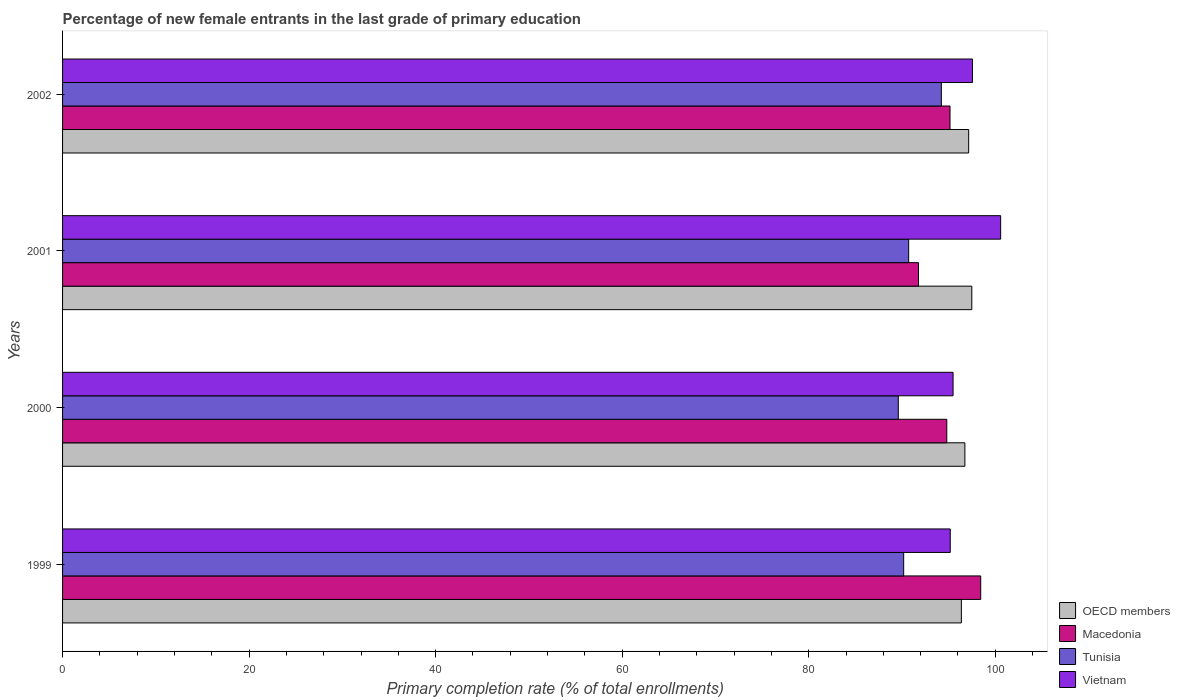How many different coloured bars are there?
Your answer should be compact. 4. How many groups of bars are there?
Your answer should be very brief. 4. Are the number of bars on each tick of the Y-axis equal?
Keep it short and to the point. Yes. How many bars are there on the 2nd tick from the bottom?
Your answer should be very brief. 4. What is the label of the 3rd group of bars from the top?
Your answer should be very brief. 2000. In how many cases, is the number of bars for a given year not equal to the number of legend labels?
Provide a short and direct response. 0. What is the percentage of new female entrants in Macedonia in 2000?
Offer a very short reply. 94.8. Across all years, what is the maximum percentage of new female entrants in OECD members?
Offer a very short reply. 97.48. Across all years, what is the minimum percentage of new female entrants in Macedonia?
Offer a terse response. 91.77. In which year was the percentage of new female entrants in OECD members maximum?
Provide a succinct answer. 2001. In which year was the percentage of new female entrants in OECD members minimum?
Ensure brevity in your answer.  1999. What is the total percentage of new female entrants in Macedonia in the graph?
Ensure brevity in your answer.  380.16. What is the difference between the percentage of new female entrants in OECD members in 2001 and that in 2002?
Offer a terse response. 0.34. What is the difference between the percentage of new female entrants in OECD members in 2001 and the percentage of new female entrants in Vietnam in 2002?
Keep it short and to the point. -0.07. What is the average percentage of new female entrants in Vietnam per year?
Provide a succinct answer. 97.2. In the year 1999, what is the difference between the percentage of new female entrants in Tunisia and percentage of new female entrants in Vietnam?
Give a very brief answer. -4.99. What is the ratio of the percentage of new female entrants in Vietnam in 1999 to that in 2002?
Make the answer very short. 0.98. What is the difference between the highest and the second highest percentage of new female entrants in Macedonia?
Make the answer very short. 3.29. What is the difference between the highest and the lowest percentage of new female entrants in Vietnam?
Provide a succinct answer. 5.4. Is the sum of the percentage of new female entrants in Vietnam in 2000 and 2001 greater than the maximum percentage of new female entrants in Macedonia across all years?
Keep it short and to the point. Yes. Is it the case that in every year, the sum of the percentage of new female entrants in Tunisia and percentage of new female entrants in OECD members is greater than the sum of percentage of new female entrants in Macedonia and percentage of new female entrants in Vietnam?
Offer a very short reply. No. What does the 1st bar from the top in 2000 represents?
Your answer should be compact. Vietnam. What does the 3rd bar from the bottom in 2001 represents?
Provide a succinct answer. Tunisia. How many years are there in the graph?
Your response must be concise. 4. Are the values on the major ticks of X-axis written in scientific E-notation?
Your answer should be very brief. No. Does the graph contain any zero values?
Give a very brief answer. No. Does the graph contain grids?
Ensure brevity in your answer.  No. What is the title of the graph?
Keep it short and to the point. Percentage of new female entrants in the last grade of primary education. What is the label or title of the X-axis?
Make the answer very short. Primary completion rate (% of total enrollments). What is the Primary completion rate (% of total enrollments) of OECD members in 1999?
Offer a terse response. 96.37. What is the Primary completion rate (% of total enrollments) in Macedonia in 1999?
Offer a terse response. 98.44. What is the Primary completion rate (% of total enrollments) in Tunisia in 1999?
Your answer should be compact. 90.18. What is the Primary completion rate (% of total enrollments) in Vietnam in 1999?
Keep it short and to the point. 95.17. What is the Primary completion rate (% of total enrollments) in OECD members in 2000?
Offer a terse response. 96.74. What is the Primary completion rate (% of total enrollments) of Macedonia in 2000?
Make the answer very short. 94.8. What is the Primary completion rate (% of total enrollments) of Tunisia in 2000?
Your response must be concise. 89.6. What is the Primary completion rate (% of total enrollments) in Vietnam in 2000?
Your answer should be very brief. 95.48. What is the Primary completion rate (% of total enrollments) in OECD members in 2001?
Your answer should be very brief. 97.48. What is the Primary completion rate (% of total enrollments) in Macedonia in 2001?
Make the answer very short. 91.77. What is the Primary completion rate (% of total enrollments) of Tunisia in 2001?
Give a very brief answer. 90.72. What is the Primary completion rate (% of total enrollments) of Vietnam in 2001?
Ensure brevity in your answer.  100.58. What is the Primary completion rate (% of total enrollments) of OECD members in 2002?
Your answer should be very brief. 97.15. What is the Primary completion rate (% of total enrollments) of Macedonia in 2002?
Provide a succinct answer. 95.15. What is the Primary completion rate (% of total enrollments) in Tunisia in 2002?
Keep it short and to the point. 94.22. What is the Primary completion rate (% of total enrollments) in Vietnam in 2002?
Make the answer very short. 97.55. Across all years, what is the maximum Primary completion rate (% of total enrollments) in OECD members?
Offer a very short reply. 97.48. Across all years, what is the maximum Primary completion rate (% of total enrollments) of Macedonia?
Provide a short and direct response. 98.44. Across all years, what is the maximum Primary completion rate (% of total enrollments) of Tunisia?
Offer a very short reply. 94.22. Across all years, what is the maximum Primary completion rate (% of total enrollments) in Vietnam?
Offer a terse response. 100.58. Across all years, what is the minimum Primary completion rate (% of total enrollments) in OECD members?
Give a very brief answer. 96.37. Across all years, what is the minimum Primary completion rate (% of total enrollments) of Macedonia?
Ensure brevity in your answer.  91.77. Across all years, what is the minimum Primary completion rate (% of total enrollments) in Tunisia?
Provide a short and direct response. 89.6. Across all years, what is the minimum Primary completion rate (% of total enrollments) in Vietnam?
Provide a succinct answer. 95.17. What is the total Primary completion rate (% of total enrollments) in OECD members in the graph?
Make the answer very short. 387.74. What is the total Primary completion rate (% of total enrollments) in Macedonia in the graph?
Offer a terse response. 380.16. What is the total Primary completion rate (% of total enrollments) of Tunisia in the graph?
Keep it short and to the point. 364.72. What is the total Primary completion rate (% of total enrollments) of Vietnam in the graph?
Offer a terse response. 388.78. What is the difference between the Primary completion rate (% of total enrollments) of OECD members in 1999 and that in 2000?
Offer a very short reply. -0.38. What is the difference between the Primary completion rate (% of total enrollments) in Macedonia in 1999 and that in 2000?
Keep it short and to the point. 3.64. What is the difference between the Primary completion rate (% of total enrollments) in Tunisia in 1999 and that in 2000?
Your answer should be compact. 0.58. What is the difference between the Primary completion rate (% of total enrollments) in Vietnam in 1999 and that in 2000?
Provide a short and direct response. -0.3. What is the difference between the Primary completion rate (% of total enrollments) in OECD members in 1999 and that in 2001?
Ensure brevity in your answer.  -1.12. What is the difference between the Primary completion rate (% of total enrollments) of Macedonia in 1999 and that in 2001?
Ensure brevity in your answer.  6.67. What is the difference between the Primary completion rate (% of total enrollments) in Tunisia in 1999 and that in 2001?
Offer a terse response. -0.53. What is the difference between the Primary completion rate (% of total enrollments) of Vietnam in 1999 and that in 2001?
Ensure brevity in your answer.  -5.4. What is the difference between the Primary completion rate (% of total enrollments) in OECD members in 1999 and that in 2002?
Offer a very short reply. -0.78. What is the difference between the Primary completion rate (% of total enrollments) of Macedonia in 1999 and that in 2002?
Provide a short and direct response. 3.29. What is the difference between the Primary completion rate (% of total enrollments) in Tunisia in 1999 and that in 2002?
Your response must be concise. -4.04. What is the difference between the Primary completion rate (% of total enrollments) in Vietnam in 1999 and that in 2002?
Offer a terse response. -2.38. What is the difference between the Primary completion rate (% of total enrollments) of OECD members in 2000 and that in 2001?
Provide a succinct answer. -0.74. What is the difference between the Primary completion rate (% of total enrollments) of Macedonia in 2000 and that in 2001?
Your response must be concise. 3.03. What is the difference between the Primary completion rate (% of total enrollments) of Tunisia in 2000 and that in 2001?
Offer a terse response. -1.11. What is the difference between the Primary completion rate (% of total enrollments) in Vietnam in 2000 and that in 2001?
Offer a terse response. -5.1. What is the difference between the Primary completion rate (% of total enrollments) of OECD members in 2000 and that in 2002?
Offer a very short reply. -0.4. What is the difference between the Primary completion rate (% of total enrollments) in Macedonia in 2000 and that in 2002?
Your answer should be very brief. -0.34. What is the difference between the Primary completion rate (% of total enrollments) in Tunisia in 2000 and that in 2002?
Give a very brief answer. -4.62. What is the difference between the Primary completion rate (% of total enrollments) of Vietnam in 2000 and that in 2002?
Your answer should be very brief. -2.08. What is the difference between the Primary completion rate (% of total enrollments) in OECD members in 2001 and that in 2002?
Your answer should be compact. 0.34. What is the difference between the Primary completion rate (% of total enrollments) in Macedonia in 2001 and that in 2002?
Provide a short and direct response. -3.38. What is the difference between the Primary completion rate (% of total enrollments) in Tunisia in 2001 and that in 2002?
Offer a terse response. -3.51. What is the difference between the Primary completion rate (% of total enrollments) of Vietnam in 2001 and that in 2002?
Offer a very short reply. 3.02. What is the difference between the Primary completion rate (% of total enrollments) in OECD members in 1999 and the Primary completion rate (% of total enrollments) in Macedonia in 2000?
Ensure brevity in your answer.  1.56. What is the difference between the Primary completion rate (% of total enrollments) of OECD members in 1999 and the Primary completion rate (% of total enrollments) of Tunisia in 2000?
Keep it short and to the point. 6.76. What is the difference between the Primary completion rate (% of total enrollments) in OECD members in 1999 and the Primary completion rate (% of total enrollments) in Vietnam in 2000?
Your response must be concise. 0.89. What is the difference between the Primary completion rate (% of total enrollments) in Macedonia in 1999 and the Primary completion rate (% of total enrollments) in Tunisia in 2000?
Your response must be concise. 8.84. What is the difference between the Primary completion rate (% of total enrollments) of Macedonia in 1999 and the Primary completion rate (% of total enrollments) of Vietnam in 2000?
Keep it short and to the point. 2.96. What is the difference between the Primary completion rate (% of total enrollments) in Tunisia in 1999 and the Primary completion rate (% of total enrollments) in Vietnam in 2000?
Offer a terse response. -5.3. What is the difference between the Primary completion rate (% of total enrollments) of OECD members in 1999 and the Primary completion rate (% of total enrollments) of Macedonia in 2001?
Offer a terse response. 4.6. What is the difference between the Primary completion rate (% of total enrollments) of OECD members in 1999 and the Primary completion rate (% of total enrollments) of Tunisia in 2001?
Provide a succinct answer. 5.65. What is the difference between the Primary completion rate (% of total enrollments) in OECD members in 1999 and the Primary completion rate (% of total enrollments) in Vietnam in 2001?
Provide a succinct answer. -4.21. What is the difference between the Primary completion rate (% of total enrollments) in Macedonia in 1999 and the Primary completion rate (% of total enrollments) in Tunisia in 2001?
Your response must be concise. 7.73. What is the difference between the Primary completion rate (% of total enrollments) of Macedonia in 1999 and the Primary completion rate (% of total enrollments) of Vietnam in 2001?
Offer a very short reply. -2.14. What is the difference between the Primary completion rate (% of total enrollments) of Tunisia in 1999 and the Primary completion rate (% of total enrollments) of Vietnam in 2001?
Keep it short and to the point. -10.4. What is the difference between the Primary completion rate (% of total enrollments) of OECD members in 1999 and the Primary completion rate (% of total enrollments) of Macedonia in 2002?
Give a very brief answer. 1.22. What is the difference between the Primary completion rate (% of total enrollments) of OECD members in 1999 and the Primary completion rate (% of total enrollments) of Tunisia in 2002?
Your response must be concise. 2.14. What is the difference between the Primary completion rate (% of total enrollments) in OECD members in 1999 and the Primary completion rate (% of total enrollments) in Vietnam in 2002?
Provide a short and direct response. -1.19. What is the difference between the Primary completion rate (% of total enrollments) of Macedonia in 1999 and the Primary completion rate (% of total enrollments) of Tunisia in 2002?
Offer a very short reply. 4.22. What is the difference between the Primary completion rate (% of total enrollments) in Macedonia in 1999 and the Primary completion rate (% of total enrollments) in Vietnam in 2002?
Keep it short and to the point. 0.89. What is the difference between the Primary completion rate (% of total enrollments) in Tunisia in 1999 and the Primary completion rate (% of total enrollments) in Vietnam in 2002?
Ensure brevity in your answer.  -7.37. What is the difference between the Primary completion rate (% of total enrollments) of OECD members in 2000 and the Primary completion rate (% of total enrollments) of Macedonia in 2001?
Provide a succinct answer. 4.97. What is the difference between the Primary completion rate (% of total enrollments) in OECD members in 2000 and the Primary completion rate (% of total enrollments) in Tunisia in 2001?
Make the answer very short. 6.03. What is the difference between the Primary completion rate (% of total enrollments) in OECD members in 2000 and the Primary completion rate (% of total enrollments) in Vietnam in 2001?
Provide a succinct answer. -3.83. What is the difference between the Primary completion rate (% of total enrollments) of Macedonia in 2000 and the Primary completion rate (% of total enrollments) of Tunisia in 2001?
Your answer should be compact. 4.09. What is the difference between the Primary completion rate (% of total enrollments) in Macedonia in 2000 and the Primary completion rate (% of total enrollments) in Vietnam in 2001?
Keep it short and to the point. -5.77. What is the difference between the Primary completion rate (% of total enrollments) of Tunisia in 2000 and the Primary completion rate (% of total enrollments) of Vietnam in 2001?
Give a very brief answer. -10.97. What is the difference between the Primary completion rate (% of total enrollments) in OECD members in 2000 and the Primary completion rate (% of total enrollments) in Macedonia in 2002?
Offer a very short reply. 1.6. What is the difference between the Primary completion rate (% of total enrollments) in OECD members in 2000 and the Primary completion rate (% of total enrollments) in Tunisia in 2002?
Give a very brief answer. 2.52. What is the difference between the Primary completion rate (% of total enrollments) of OECD members in 2000 and the Primary completion rate (% of total enrollments) of Vietnam in 2002?
Offer a very short reply. -0.81. What is the difference between the Primary completion rate (% of total enrollments) in Macedonia in 2000 and the Primary completion rate (% of total enrollments) in Tunisia in 2002?
Ensure brevity in your answer.  0.58. What is the difference between the Primary completion rate (% of total enrollments) of Macedonia in 2000 and the Primary completion rate (% of total enrollments) of Vietnam in 2002?
Your answer should be very brief. -2.75. What is the difference between the Primary completion rate (% of total enrollments) in Tunisia in 2000 and the Primary completion rate (% of total enrollments) in Vietnam in 2002?
Your answer should be compact. -7.95. What is the difference between the Primary completion rate (% of total enrollments) of OECD members in 2001 and the Primary completion rate (% of total enrollments) of Macedonia in 2002?
Your answer should be very brief. 2.34. What is the difference between the Primary completion rate (% of total enrollments) of OECD members in 2001 and the Primary completion rate (% of total enrollments) of Tunisia in 2002?
Your answer should be compact. 3.26. What is the difference between the Primary completion rate (% of total enrollments) of OECD members in 2001 and the Primary completion rate (% of total enrollments) of Vietnam in 2002?
Your answer should be very brief. -0.07. What is the difference between the Primary completion rate (% of total enrollments) in Macedonia in 2001 and the Primary completion rate (% of total enrollments) in Tunisia in 2002?
Ensure brevity in your answer.  -2.45. What is the difference between the Primary completion rate (% of total enrollments) in Macedonia in 2001 and the Primary completion rate (% of total enrollments) in Vietnam in 2002?
Keep it short and to the point. -5.78. What is the difference between the Primary completion rate (% of total enrollments) of Tunisia in 2001 and the Primary completion rate (% of total enrollments) of Vietnam in 2002?
Make the answer very short. -6.84. What is the average Primary completion rate (% of total enrollments) of OECD members per year?
Make the answer very short. 96.94. What is the average Primary completion rate (% of total enrollments) of Macedonia per year?
Your answer should be compact. 95.04. What is the average Primary completion rate (% of total enrollments) of Tunisia per year?
Your response must be concise. 91.18. What is the average Primary completion rate (% of total enrollments) in Vietnam per year?
Your answer should be very brief. 97.2. In the year 1999, what is the difference between the Primary completion rate (% of total enrollments) in OECD members and Primary completion rate (% of total enrollments) in Macedonia?
Provide a succinct answer. -2.08. In the year 1999, what is the difference between the Primary completion rate (% of total enrollments) in OECD members and Primary completion rate (% of total enrollments) in Tunisia?
Ensure brevity in your answer.  6.18. In the year 1999, what is the difference between the Primary completion rate (% of total enrollments) of OECD members and Primary completion rate (% of total enrollments) of Vietnam?
Keep it short and to the point. 1.19. In the year 1999, what is the difference between the Primary completion rate (% of total enrollments) of Macedonia and Primary completion rate (% of total enrollments) of Tunisia?
Make the answer very short. 8.26. In the year 1999, what is the difference between the Primary completion rate (% of total enrollments) of Macedonia and Primary completion rate (% of total enrollments) of Vietnam?
Make the answer very short. 3.27. In the year 1999, what is the difference between the Primary completion rate (% of total enrollments) of Tunisia and Primary completion rate (% of total enrollments) of Vietnam?
Your response must be concise. -4.99. In the year 2000, what is the difference between the Primary completion rate (% of total enrollments) of OECD members and Primary completion rate (% of total enrollments) of Macedonia?
Offer a terse response. 1.94. In the year 2000, what is the difference between the Primary completion rate (% of total enrollments) in OECD members and Primary completion rate (% of total enrollments) in Tunisia?
Your answer should be very brief. 7.14. In the year 2000, what is the difference between the Primary completion rate (% of total enrollments) of OECD members and Primary completion rate (% of total enrollments) of Vietnam?
Offer a terse response. 1.27. In the year 2000, what is the difference between the Primary completion rate (% of total enrollments) in Macedonia and Primary completion rate (% of total enrollments) in Tunisia?
Make the answer very short. 5.2. In the year 2000, what is the difference between the Primary completion rate (% of total enrollments) in Macedonia and Primary completion rate (% of total enrollments) in Vietnam?
Provide a short and direct response. -0.67. In the year 2000, what is the difference between the Primary completion rate (% of total enrollments) in Tunisia and Primary completion rate (% of total enrollments) in Vietnam?
Make the answer very short. -5.87. In the year 2001, what is the difference between the Primary completion rate (% of total enrollments) in OECD members and Primary completion rate (% of total enrollments) in Macedonia?
Give a very brief answer. 5.72. In the year 2001, what is the difference between the Primary completion rate (% of total enrollments) of OECD members and Primary completion rate (% of total enrollments) of Tunisia?
Provide a short and direct response. 6.77. In the year 2001, what is the difference between the Primary completion rate (% of total enrollments) in OECD members and Primary completion rate (% of total enrollments) in Vietnam?
Ensure brevity in your answer.  -3.09. In the year 2001, what is the difference between the Primary completion rate (% of total enrollments) of Macedonia and Primary completion rate (% of total enrollments) of Tunisia?
Provide a short and direct response. 1.05. In the year 2001, what is the difference between the Primary completion rate (% of total enrollments) of Macedonia and Primary completion rate (% of total enrollments) of Vietnam?
Your answer should be compact. -8.81. In the year 2001, what is the difference between the Primary completion rate (% of total enrollments) in Tunisia and Primary completion rate (% of total enrollments) in Vietnam?
Keep it short and to the point. -9.86. In the year 2002, what is the difference between the Primary completion rate (% of total enrollments) in OECD members and Primary completion rate (% of total enrollments) in Macedonia?
Make the answer very short. 2. In the year 2002, what is the difference between the Primary completion rate (% of total enrollments) in OECD members and Primary completion rate (% of total enrollments) in Tunisia?
Your response must be concise. 2.93. In the year 2002, what is the difference between the Primary completion rate (% of total enrollments) in OECD members and Primary completion rate (% of total enrollments) in Vietnam?
Ensure brevity in your answer.  -0.41. In the year 2002, what is the difference between the Primary completion rate (% of total enrollments) of Macedonia and Primary completion rate (% of total enrollments) of Tunisia?
Ensure brevity in your answer.  0.93. In the year 2002, what is the difference between the Primary completion rate (% of total enrollments) of Macedonia and Primary completion rate (% of total enrollments) of Vietnam?
Your response must be concise. -2.41. In the year 2002, what is the difference between the Primary completion rate (% of total enrollments) in Tunisia and Primary completion rate (% of total enrollments) in Vietnam?
Provide a succinct answer. -3.33. What is the ratio of the Primary completion rate (% of total enrollments) in OECD members in 1999 to that in 2000?
Your answer should be very brief. 1. What is the ratio of the Primary completion rate (% of total enrollments) of Macedonia in 1999 to that in 2000?
Provide a short and direct response. 1.04. What is the ratio of the Primary completion rate (% of total enrollments) of Tunisia in 1999 to that in 2000?
Your answer should be compact. 1.01. What is the ratio of the Primary completion rate (% of total enrollments) in Vietnam in 1999 to that in 2000?
Offer a very short reply. 1. What is the ratio of the Primary completion rate (% of total enrollments) in Macedonia in 1999 to that in 2001?
Your response must be concise. 1.07. What is the ratio of the Primary completion rate (% of total enrollments) of Vietnam in 1999 to that in 2001?
Provide a succinct answer. 0.95. What is the ratio of the Primary completion rate (% of total enrollments) of Macedonia in 1999 to that in 2002?
Ensure brevity in your answer.  1.03. What is the ratio of the Primary completion rate (% of total enrollments) in Tunisia in 1999 to that in 2002?
Your answer should be very brief. 0.96. What is the ratio of the Primary completion rate (% of total enrollments) of Vietnam in 1999 to that in 2002?
Your response must be concise. 0.98. What is the ratio of the Primary completion rate (% of total enrollments) of OECD members in 2000 to that in 2001?
Your answer should be very brief. 0.99. What is the ratio of the Primary completion rate (% of total enrollments) of Macedonia in 2000 to that in 2001?
Your response must be concise. 1.03. What is the ratio of the Primary completion rate (% of total enrollments) in Tunisia in 2000 to that in 2001?
Give a very brief answer. 0.99. What is the ratio of the Primary completion rate (% of total enrollments) of Vietnam in 2000 to that in 2001?
Make the answer very short. 0.95. What is the ratio of the Primary completion rate (% of total enrollments) in OECD members in 2000 to that in 2002?
Provide a short and direct response. 1. What is the ratio of the Primary completion rate (% of total enrollments) of Tunisia in 2000 to that in 2002?
Provide a short and direct response. 0.95. What is the ratio of the Primary completion rate (% of total enrollments) of Vietnam in 2000 to that in 2002?
Make the answer very short. 0.98. What is the ratio of the Primary completion rate (% of total enrollments) in OECD members in 2001 to that in 2002?
Make the answer very short. 1. What is the ratio of the Primary completion rate (% of total enrollments) in Macedonia in 2001 to that in 2002?
Your response must be concise. 0.96. What is the ratio of the Primary completion rate (% of total enrollments) in Tunisia in 2001 to that in 2002?
Ensure brevity in your answer.  0.96. What is the ratio of the Primary completion rate (% of total enrollments) in Vietnam in 2001 to that in 2002?
Keep it short and to the point. 1.03. What is the difference between the highest and the second highest Primary completion rate (% of total enrollments) in OECD members?
Offer a terse response. 0.34. What is the difference between the highest and the second highest Primary completion rate (% of total enrollments) in Macedonia?
Keep it short and to the point. 3.29. What is the difference between the highest and the second highest Primary completion rate (% of total enrollments) of Tunisia?
Ensure brevity in your answer.  3.51. What is the difference between the highest and the second highest Primary completion rate (% of total enrollments) of Vietnam?
Offer a very short reply. 3.02. What is the difference between the highest and the lowest Primary completion rate (% of total enrollments) of OECD members?
Ensure brevity in your answer.  1.12. What is the difference between the highest and the lowest Primary completion rate (% of total enrollments) in Macedonia?
Offer a terse response. 6.67. What is the difference between the highest and the lowest Primary completion rate (% of total enrollments) in Tunisia?
Provide a short and direct response. 4.62. What is the difference between the highest and the lowest Primary completion rate (% of total enrollments) of Vietnam?
Provide a short and direct response. 5.4. 